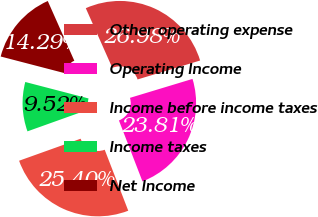Convert chart. <chart><loc_0><loc_0><loc_500><loc_500><pie_chart><fcel>Other operating expense<fcel>Operating Income<fcel>Income before income taxes<fcel>Income taxes<fcel>Net Income<nl><fcel>26.98%<fcel>23.81%<fcel>25.4%<fcel>9.52%<fcel>14.29%<nl></chart> 